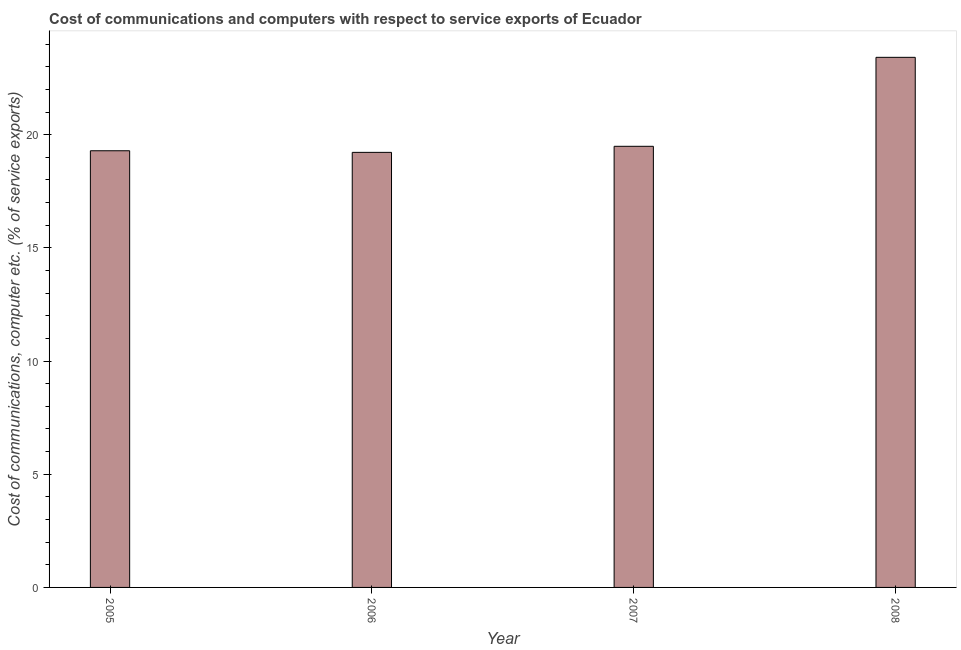What is the title of the graph?
Keep it short and to the point. Cost of communications and computers with respect to service exports of Ecuador. What is the label or title of the Y-axis?
Provide a short and direct response. Cost of communications, computer etc. (% of service exports). What is the cost of communications and computer in 2005?
Offer a very short reply. 19.29. Across all years, what is the maximum cost of communications and computer?
Offer a very short reply. 23.42. Across all years, what is the minimum cost of communications and computer?
Offer a terse response. 19.22. In which year was the cost of communications and computer maximum?
Your answer should be compact. 2008. What is the sum of the cost of communications and computer?
Ensure brevity in your answer.  81.42. What is the difference between the cost of communications and computer in 2005 and 2007?
Make the answer very short. -0.2. What is the average cost of communications and computer per year?
Provide a succinct answer. 20.36. What is the median cost of communications and computer?
Make the answer very short. 19.39. In how many years, is the cost of communications and computer greater than 21 %?
Make the answer very short. 1. Do a majority of the years between 2007 and 2005 (inclusive) have cost of communications and computer greater than 1 %?
Your response must be concise. Yes. What is the ratio of the cost of communications and computer in 2006 to that in 2008?
Your response must be concise. 0.82. Is the difference between the cost of communications and computer in 2005 and 2008 greater than the difference between any two years?
Your answer should be compact. No. What is the difference between the highest and the second highest cost of communications and computer?
Your response must be concise. 3.93. What is the difference between the highest and the lowest cost of communications and computer?
Make the answer very short. 4.2. How many bars are there?
Give a very brief answer. 4. Are all the bars in the graph horizontal?
Give a very brief answer. No. How many years are there in the graph?
Keep it short and to the point. 4. Are the values on the major ticks of Y-axis written in scientific E-notation?
Give a very brief answer. No. What is the Cost of communications, computer etc. (% of service exports) in 2005?
Ensure brevity in your answer.  19.29. What is the Cost of communications, computer etc. (% of service exports) of 2006?
Provide a succinct answer. 19.22. What is the Cost of communications, computer etc. (% of service exports) of 2007?
Your response must be concise. 19.49. What is the Cost of communications, computer etc. (% of service exports) of 2008?
Your answer should be compact. 23.42. What is the difference between the Cost of communications, computer etc. (% of service exports) in 2005 and 2006?
Provide a short and direct response. 0.07. What is the difference between the Cost of communications, computer etc. (% of service exports) in 2005 and 2007?
Offer a very short reply. -0.2. What is the difference between the Cost of communications, computer etc. (% of service exports) in 2005 and 2008?
Offer a terse response. -4.13. What is the difference between the Cost of communications, computer etc. (% of service exports) in 2006 and 2007?
Your answer should be compact. -0.27. What is the difference between the Cost of communications, computer etc. (% of service exports) in 2006 and 2008?
Offer a terse response. -4.2. What is the difference between the Cost of communications, computer etc. (% of service exports) in 2007 and 2008?
Offer a terse response. -3.93. What is the ratio of the Cost of communications, computer etc. (% of service exports) in 2005 to that in 2007?
Provide a succinct answer. 0.99. What is the ratio of the Cost of communications, computer etc. (% of service exports) in 2005 to that in 2008?
Provide a short and direct response. 0.82. What is the ratio of the Cost of communications, computer etc. (% of service exports) in 2006 to that in 2007?
Keep it short and to the point. 0.99. What is the ratio of the Cost of communications, computer etc. (% of service exports) in 2006 to that in 2008?
Ensure brevity in your answer.  0.82. What is the ratio of the Cost of communications, computer etc. (% of service exports) in 2007 to that in 2008?
Your response must be concise. 0.83. 